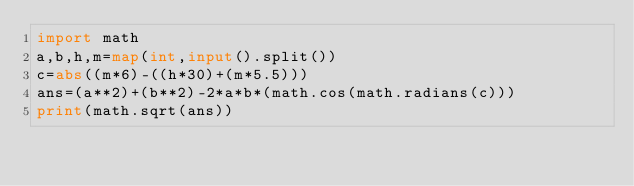Convert code to text. <code><loc_0><loc_0><loc_500><loc_500><_Python_>import math
a,b,h,m=map(int,input().split())
c=abs((m*6)-((h*30)+(m*5.5)))
ans=(a**2)+(b**2)-2*a*b*(math.cos(math.radians(c)))
print(math.sqrt(ans))</code> 